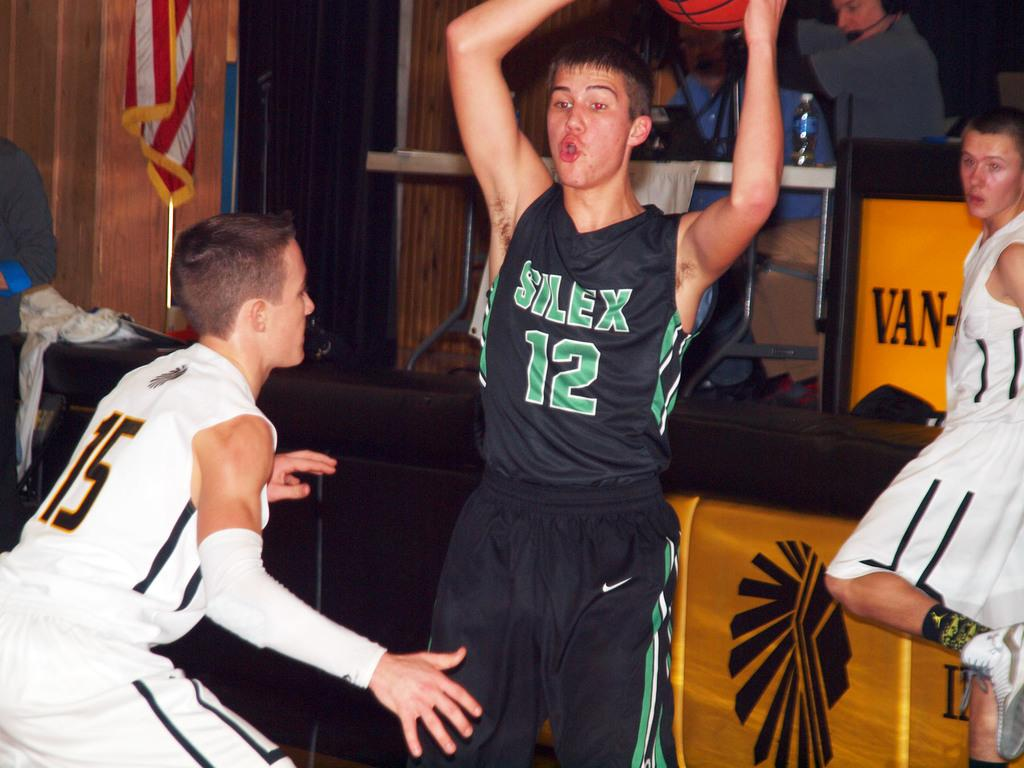<image>
Describe the image concisely. A young man wearing a Silex jersey tries to avoid an opponent to pass a basketball. 